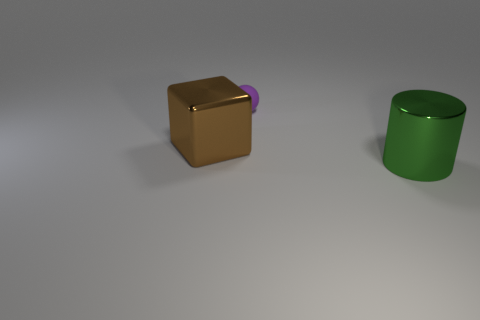Add 2 big green metallic things. How many objects exist? 5 Subtract all spheres. How many objects are left? 2 Subtract 0 green cubes. How many objects are left? 3 Subtract all large brown metallic blocks. Subtract all large yellow blocks. How many objects are left? 2 Add 1 green cylinders. How many green cylinders are left? 2 Add 3 big shiny cylinders. How many big shiny cylinders exist? 4 